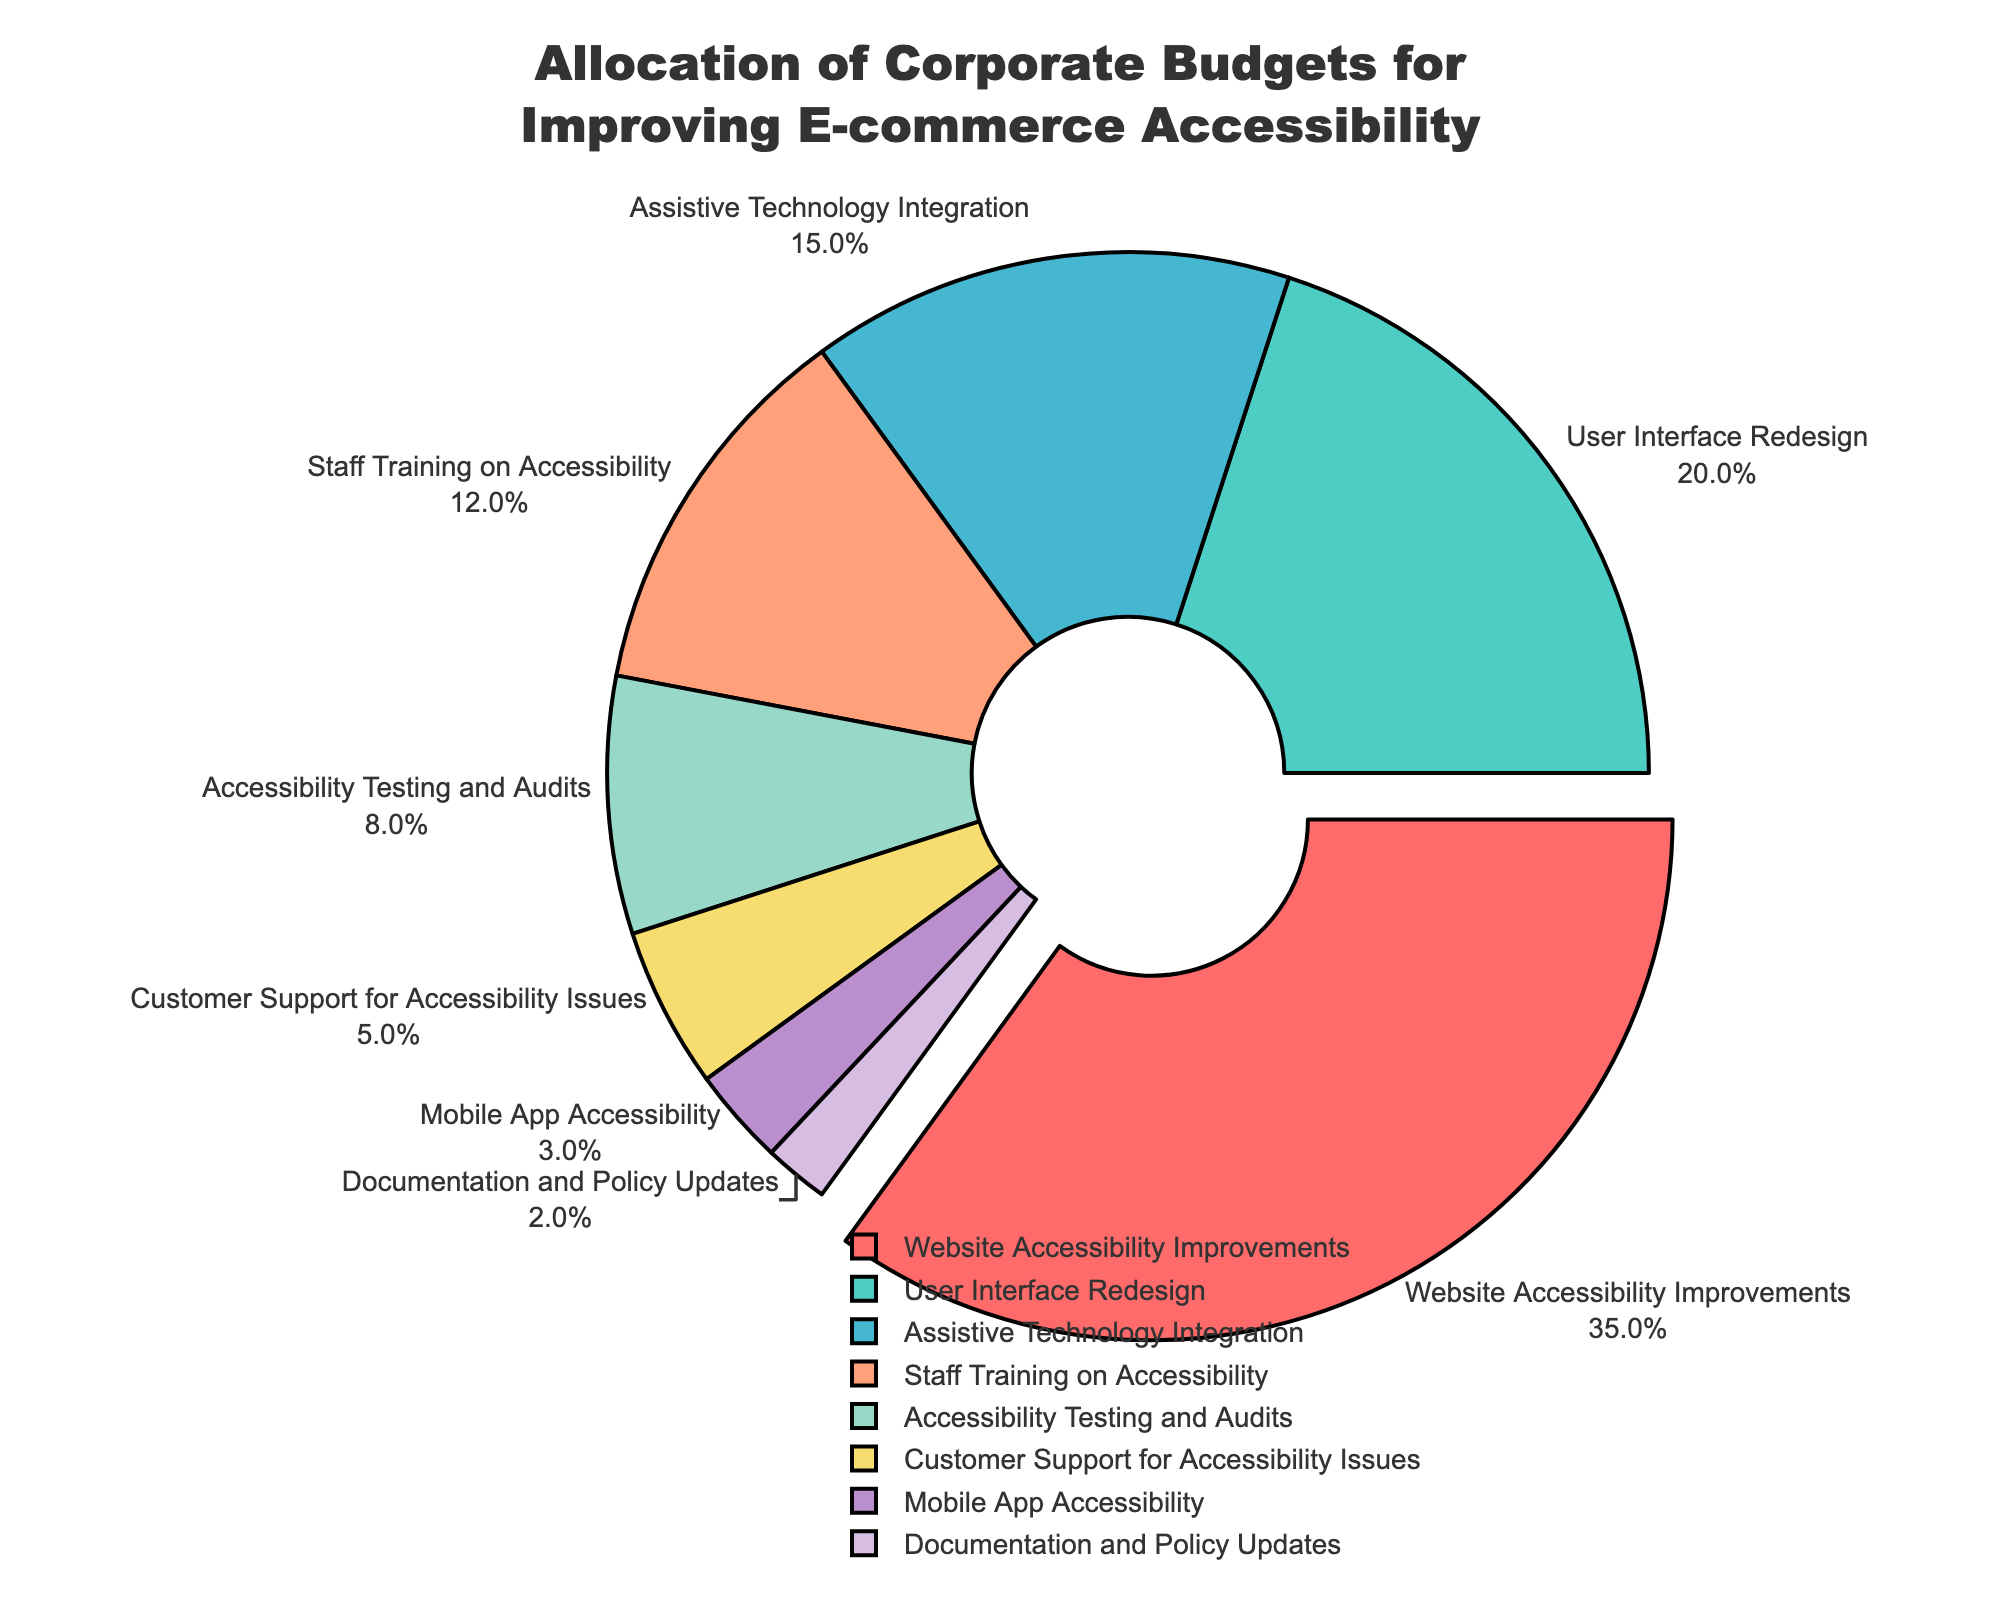What category receives the largest portion of the budget? The largest portion of the budget is indicated by the segment with the highest percentage. According to the pie chart, 'Website Accessibility Improvements' has the highest percentage at 35%.
Answer: Website Accessibility Improvements How does the percentage allocated to 'Staff Training on Accessibility' compare to 'Assistive Technology Integration'? To compare these categories, observe their respective percentages from the pie chart. 'Assistive Technology Integration' is 15% while 'Staff Training on Accessibility' is 12%.
Answer: Staff Training on Accessibility is 3% less than Assistive Technology Integration What is the combined percentage for 'Customer Support for Accessibility Issues' and 'Mobile App Accessibility'? Add the percentages of 'Customer Support for Accessibility Issues' (5%) and 'Mobile App Accessibility' (3%), which yields 5% + 3% = 8%.
Answer: 8% What categories are allocated less than 5% of the budget? To determine the categories with less than 5%, observe the pie chart segments with percentages lower than 5%. These categories are 'Mobile App Accessibility' (3%) and 'Documentation and Policy Updates' (2%).
Answer: Mobile App Accessibility and Documentation and Policy Updates How much more budget percentage is allocated to 'User Interface Redesign' compared to 'Accessibility Testing and Audits'? The difference is calculated by subtracting the percentage of 'Accessibility Testing and Audits' (8%) from 'User Interface Redesign' (20%), giving 20% - 8% = 12%.
Answer: 12% Which category has been pulled out slightly from the center of the pie chart, and what is its percentage? Look for the segment separated slightly from the center, highlighted by its displacement. This category is 'Website Accessibility Improvements', which has a percentage of 35%.
Answer: Website Accessibility Improvements at 35% What is the second-largest allocation after 'Website Accessibility Improvements'? The second-largest segment is identified after noting the highest; here it is 'User Interface Redesign' with 20%.
Answer: User Interface Redesign Which categories combined make up more than half of the budget? Add the percentages progressively until the sum exceeds 50%. Starting with 'Website Accessibility Improvements' (35%) and 'User Interface Redesign' (20%), the combined total is 35% + 20% = 55%. This combination already exceeds 50%.
Answer: Website Accessibility Improvements and User Interface Redesign 